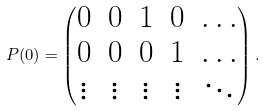<formula> <loc_0><loc_0><loc_500><loc_500>P ( 0 ) = \begin{pmatrix} 0 & 0 & 1 & 0 & \dots \\ 0 & 0 & 0 & 1 & \dots \\ \vdots & \vdots & \vdots & \vdots & \ddots \end{pmatrix} .</formula> 